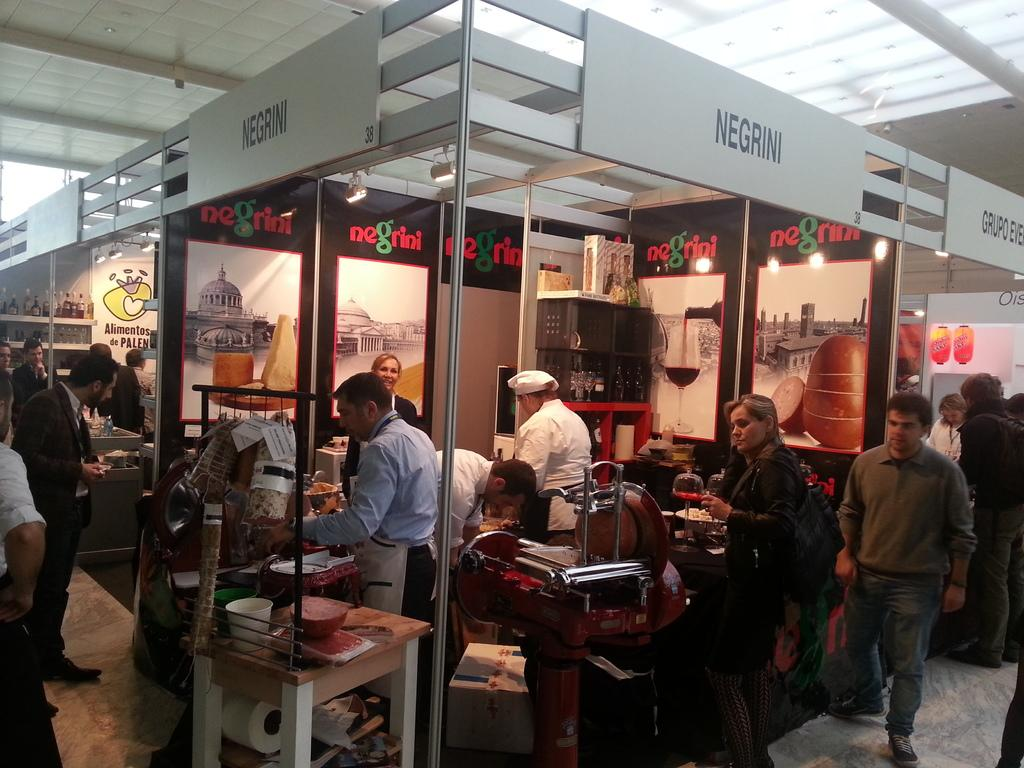What are the people doing in front of the store? The people are standing in front of a store. What activity is taking place in the store? Food is being prepared in the store. What type of furniture is present in the store? There are tables and chairs present in the store. How many stars can be seen in the image? There are no stars visible in the image. What is the value of the food being prepared in the image? The value of the food being prepared cannot be determined from the image alone. 